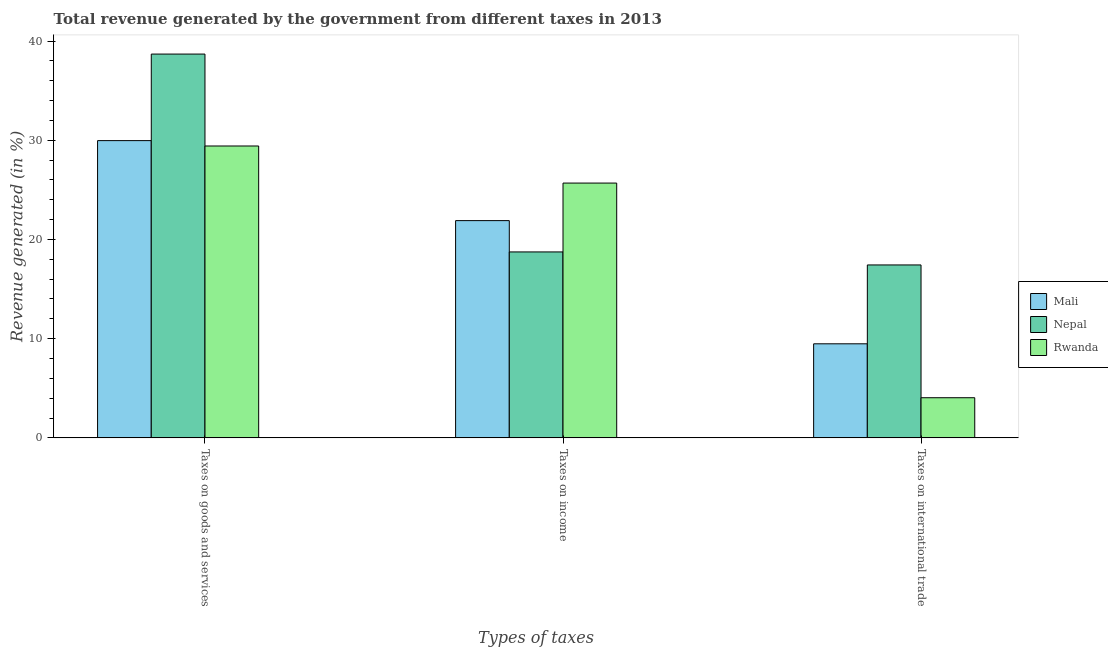How many different coloured bars are there?
Give a very brief answer. 3. How many groups of bars are there?
Your response must be concise. 3. Are the number of bars per tick equal to the number of legend labels?
Provide a short and direct response. Yes. Are the number of bars on each tick of the X-axis equal?
Keep it short and to the point. Yes. How many bars are there on the 1st tick from the right?
Give a very brief answer. 3. What is the label of the 1st group of bars from the left?
Provide a succinct answer. Taxes on goods and services. What is the percentage of revenue generated by taxes on income in Mali?
Ensure brevity in your answer.  21.9. Across all countries, what is the maximum percentage of revenue generated by tax on international trade?
Make the answer very short. 17.43. Across all countries, what is the minimum percentage of revenue generated by taxes on income?
Ensure brevity in your answer.  18.74. In which country was the percentage of revenue generated by taxes on goods and services maximum?
Keep it short and to the point. Nepal. In which country was the percentage of revenue generated by taxes on income minimum?
Give a very brief answer. Nepal. What is the total percentage of revenue generated by tax on international trade in the graph?
Your response must be concise. 30.96. What is the difference between the percentage of revenue generated by tax on international trade in Rwanda and that in Mali?
Give a very brief answer. -5.44. What is the difference between the percentage of revenue generated by taxes on goods and services in Nepal and the percentage of revenue generated by tax on international trade in Rwanda?
Your answer should be very brief. 34.64. What is the average percentage of revenue generated by taxes on goods and services per country?
Your answer should be very brief. 32.69. What is the difference between the percentage of revenue generated by tax on international trade and percentage of revenue generated by taxes on income in Rwanda?
Provide a succinct answer. -21.64. In how many countries, is the percentage of revenue generated by taxes on goods and services greater than 18 %?
Provide a succinct answer. 3. What is the ratio of the percentage of revenue generated by taxes on goods and services in Mali to that in Rwanda?
Make the answer very short. 1.02. Is the difference between the percentage of revenue generated by taxes on goods and services in Nepal and Mali greater than the difference between the percentage of revenue generated by taxes on income in Nepal and Mali?
Provide a succinct answer. Yes. What is the difference between the highest and the second highest percentage of revenue generated by taxes on goods and services?
Offer a terse response. 8.73. What is the difference between the highest and the lowest percentage of revenue generated by taxes on goods and services?
Make the answer very short. 9.27. Is the sum of the percentage of revenue generated by tax on international trade in Nepal and Rwanda greater than the maximum percentage of revenue generated by taxes on goods and services across all countries?
Provide a short and direct response. No. What does the 2nd bar from the left in Taxes on goods and services represents?
Provide a succinct answer. Nepal. What does the 2nd bar from the right in Taxes on international trade represents?
Offer a very short reply. Nepal. Is it the case that in every country, the sum of the percentage of revenue generated by taxes on goods and services and percentage of revenue generated by taxes on income is greater than the percentage of revenue generated by tax on international trade?
Your answer should be very brief. Yes. How many bars are there?
Provide a short and direct response. 9. Are the values on the major ticks of Y-axis written in scientific E-notation?
Provide a succinct answer. No. Does the graph contain grids?
Offer a very short reply. No. Where does the legend appear in the graph?
Ensure brevity in your answer.  Center right. How are the legend labels stacked?
Ensure brevity in your answer.  Vertical. What is the title of the graph?
Your answer should be compact. Total revenue generated by the government from different taxes in 2013. Does "Guinea" appear as one of the legend labels in the graph?
Your response must be concise. No. What is the label or title of the X-axis?
Your answer should be compact. Types of taxes. What is the label or title of the Y-axis?
Keep it short and to the point. Revenue generated (in %). What is the Revenue generated (in %) in Mali in Taxes on goods and services?
Make the answer very short. 29.97. What is the Revenue generated (in %) in Nepal in Taxes on goods and services?
Your answer should be very brief. 38.69. What is the Revenue generated (in %) of Rwanda in Taxes on goods and services?
Your response must be concise. 29.43. What is the Revenue generated (in %) of Mali in Taxes on income?
Your response must be concise. 21.9. What is the Revenue generated (in %) in Nepal in Taxes on income?
Provide a short and direct response. 18.74. What is the Revenue generated (in %) in Rwanda in Taxes on income?
Provide a short and direct response. 25.69. What is the Revenue generated (in %) in Mali in Taxes on international trade?
Your response must be concise. 9.48. What is the Revenue generated (in %) in Nepal in Taxes on international trade?
Offer a terse response. 17.43. What is the Revenue generated (in %) of Rwanda in Taxes on international trade?
Provide a succinct answer. 4.05. Across all Types of taxes, what is the maximum Revenue generated (in %) of Mali?
Provide a short and direct response. 29.97. Across all Types of taxes, what is the maximum Revenue generated (in %) of Nepal?
Your answer should be very brief. 38.69. Across all Types of taxes, what is the maximum Revenue generated (in %) in Rwanda?
Offer a very short reply. 29.43. Across all Types of taxes, what is the minimum Revenue generated (in %) in Mali?
Offer a very short reply. 9.48. Across all Types of taxes, what is the minimum Revenue generated (in %) of Nepal?
Give a very brief answer. 17.43. Across all Types of taxes, what is the minimum Revenue generated (in %) of Rwanda?
Make the answer very short. 4.05. What is the total Revenue generated (in %) in Mali in the graph?
Ensure brevity in your answer.  61.35. What is the total Revenue generated (in %) of Nepal in the graph?
Provide a short and direct response. 74.87. What is the total Revenue generated (in %) of Rwanda in the graph?
Keep it short and to the point. 59.16. What is the difference between the Revenue generated (in %) in Mali in Taxes on goods and services and that in Taxes on income?
Offer a terse response. 8.06. What is the difference between the Revenue generated (in %) in Nepal in Taxes on goods and services and that in Taxes on income?
Make the answer very short. 19.95. What is the difference between the Revenue generated (in %) of Rwanda in Taxes on goods and services and that in Taxes on income?
Keep it short and to the point. 3.74. What is the difference between the Revenue generated (in %) in Mali in Taxes on goods and services and that in Taxes on international trade?
Offer a very short reply. 20.48. What is the difference between the Revenue generated (in %) of Nepal in Taxes on goods and services and that in Taxes on international trade?
Make the answer very short. 21.26. What is the difference between the Revenue generated (in %) in Rwanda in Taxes on goods and services and that in Taxes on international trade?
Ensure brevity in your answer.  25.38. What is the difference between the Revenue generated (in %) of Mali in Taxes on income and that in Taxes on international trade?
Give a very brief answer. 12.42. What is the difference between the Revenue generated (in %) of Nepal in Taxes on income and that in Taxes on international trade?
Your answer should be compact. 1.31. What is the difference between the Revenue generated (in %) in Rwanda in Taxes on income and that in Taxes on international trade?
Ensure brevity in your answer.  21.64. What is the difference between the Revenue generated (in %) of Mali in Taxes on goods and services and the Revenue generated (in %) of Nepal in Taxes on income?
Keep it short and to the point. 11.22. What is the difference between the Revenue generated (in %) in Mali in Taxes on goods and services and the Revenue generated (in %) in Rwanda in Taxes on income?
Ensure brevity in your answer.  4.28. What is the difference between the Revenue generated (in %) of Nepal in Taxes on goods and services and the Revenue generated (in %) of Rwanda in Taxes on income?
Your response must be concise. 13.01. What is the difference between the Revenue generated (in %) in Mali in Taxes on goods and services and the Revenue generated (in %) in Nepal in Taxes on international trade?
Offer a terse response. 12.53. What is the difference between the Revenue generated (in %) of Mali in Taxes on goods and services and the Revenue generated (in %) of Rwanda in Taxes on international trade?
Offer a terse response. 25.92. What is the difference between the Revenue generated (in %) in Nepal in Taxes on goods and services and the Revenue generated (in %) in Rwanda in Taxes on international trade?
Your answer should be compact. 34.64. What is the difference between the Revenue generated (in %) in Mali in Taxes on income and the Revenue generated (in %) in Nepal in Taxes on international trade?
Your answer should be compact. 4.47. What is the difference between the Revenue generated (in %) in Mali in Taxes on income and the Revenue generated (in %) in Rwanda in Taxes on international trade?
Give a very brief answer. 17.86. What is the difference between the Revenue generated (in %) of Nepal in Taxes on income and the Revenue generated (in %) of Rwanda in Taxes on international trade?
Give a very brief answer. 14.7. What is the average Revenue generated (in %) of Mali per Types of taxes?
Keep it short and to the point. 20.45. What is the average Revenue generated (in %) in Nepal per Types of taxes?
Your answer should be very brief. 24.96. What is the average Revenue generated (in %) in Rwanda per Types of taxes?
Offer a very short reply. 19.72. What is the difference between the Revenue generated (in %) in Mali and Revenue generated (in %) in Nepal in Taxes on goods and services?
Offer a terse response. -8.73. What is the difference between the Revenue generated (in %) in Mali and Revenue generated (in %) in Rwanda in Taxes on goods and services?
Offer a very short reply. 0.54. What is the difference between the Revenue generated (in %) of Nepal and Revenue generated (in %) of Rwanda in Taxes on goods and services?
Provide a succinct answer. 9.27. What is the difference between the Revenue generated (in %) in Mali and Revenue generated (in %) in Nepal in Taxes on income?
Offer a very short reply. 3.16. What is the difference between the Revenue generated (in %) of Mali and Revenue generated (in %) of Rwanda in Taxes on income?
Provide a short and direct response. -3.78. What is the difference between the Revenue generated (in %) in Nepal and Revenue generated (in %) in Rwanda in Taxes on income?
Offer a very short reply. -6.94. What is the difference between the Revenue generated (in %) in Mali and Revenue generated (in %) in Nepal in Taxes on international trade?
Your answer should be very brief. -7.95. What is the difference between the Revenue generated (in %) in Mali and Revenue generated (in %) in Rwanda in Taxes on international trade?
Your answer should be compact. 5.44. What is the difference between the Revenue generated (in %) of Nepal and Revenue generated (in %) of Rwanda in Taxes on international trade?
Offer a terse response. 13.39. What is the ratio of the Revenue generated (in %) of Mali in Taxes on goods and services to that in Taxes on income?
Ensure brevity in your answer.  1.37. What is the ratio of the Revenue generated (in %) of Nepal in Taxes on goods and services to that in Taxes on income?
Keep it short and to the point. 2.06. What is the ratio of the Revenue generated (in %) of Rwanda in Taxes on goods and services to that in Taxes on income?
Give a very brief answer. 1.15. What is the ratio of the Revenue generated (in %) in Mali in Taxes on goods and services to that in Taxes on international trade?
Your answer should be very brief. 3.16. What is the ratio of the Revenue generated (in %) of Nepal in Taxes on goods and services to that in Taxes on international trade?
Provide a short and direct response. 2.22. What is the ratio of the Revenue generated (in %) of Rwanda in Taxes on goods and services to that in Taxes on international trade?
Ensure brevity in your answer.  7.27. What is the ratio of the Revenue generated (in %) in Mali in Taxes on income to that in Taxes on international trade?
Keep it short and to the point. 2.31. What is the ratio of the Revenue generated (in %) in Nepal in Taxes on income to that in Taxes on international trade?
Offer a very short reply. 1.08. What is the ratio of the Revenue generated (in %) in Rwanda in Taxes on income to that in Taxes on international trade?
Ensure brevity in your answer.  6.35. What is the difference between the highest and the second highest Revenue generated (in %) of Mali?
Make the answer very short. 8.06. What is the difference between the highest and the second highest Revenue generated (in %) in Nepal?
Give a very brief answer. 19.95. What is the difference between the highest and the second highest Revenue generated (in %) of Rwanda?
Give a very brief answer. 3.74. What is the difference between the highest and the lowest Revenue generated (in %) of Mali?
Offer a terse response. 20.48. What is the difference between the highest and the lowest Revenue generated (in %) of Nepal?
Your response must be concise. 21.26. What is the difference between the highest and the lowest Revenue generated (in %) of Rwanda?
Offer a terse response. 25.38. 